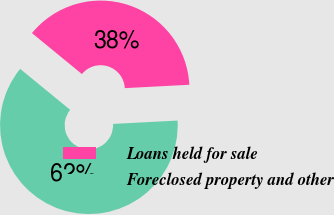Convert chart. <chart><loc_0><loc_0><loc_500><loc_500><pie_chart><fcel>Loans held for sale<fcel>Foreclosed property and other<nl><fcel>38.24%<fcel>61.76%<nl></chart> 